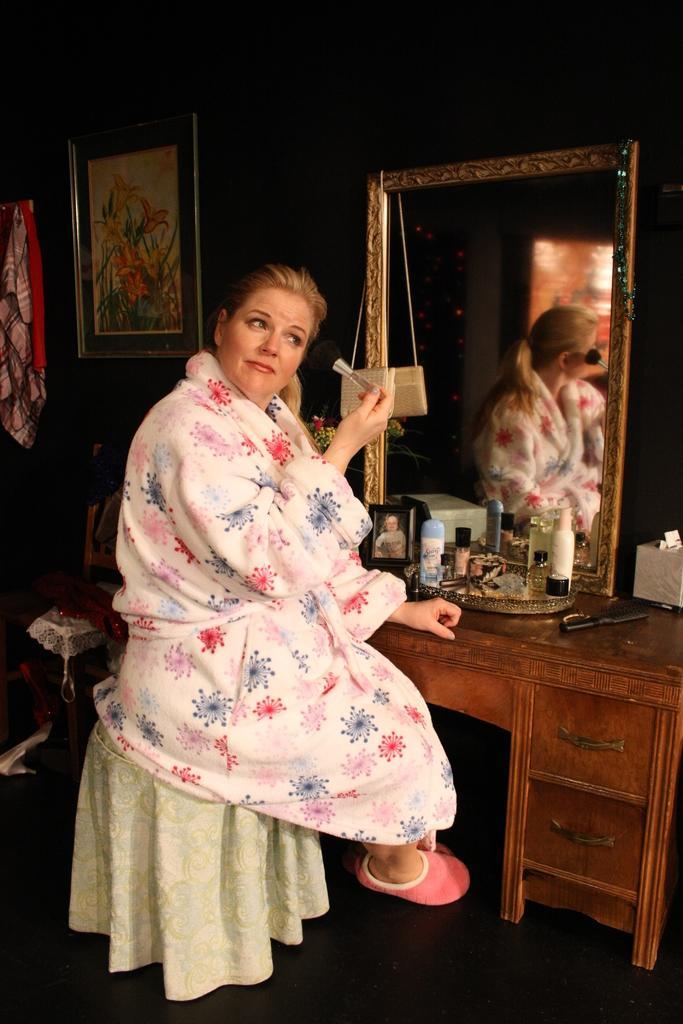Can you describe this image briefly? A woman is sitting on the stool and doing makeup to herself she wears pink color footwear there is a mirror in front of her on the left there is a photograph on the wall. 